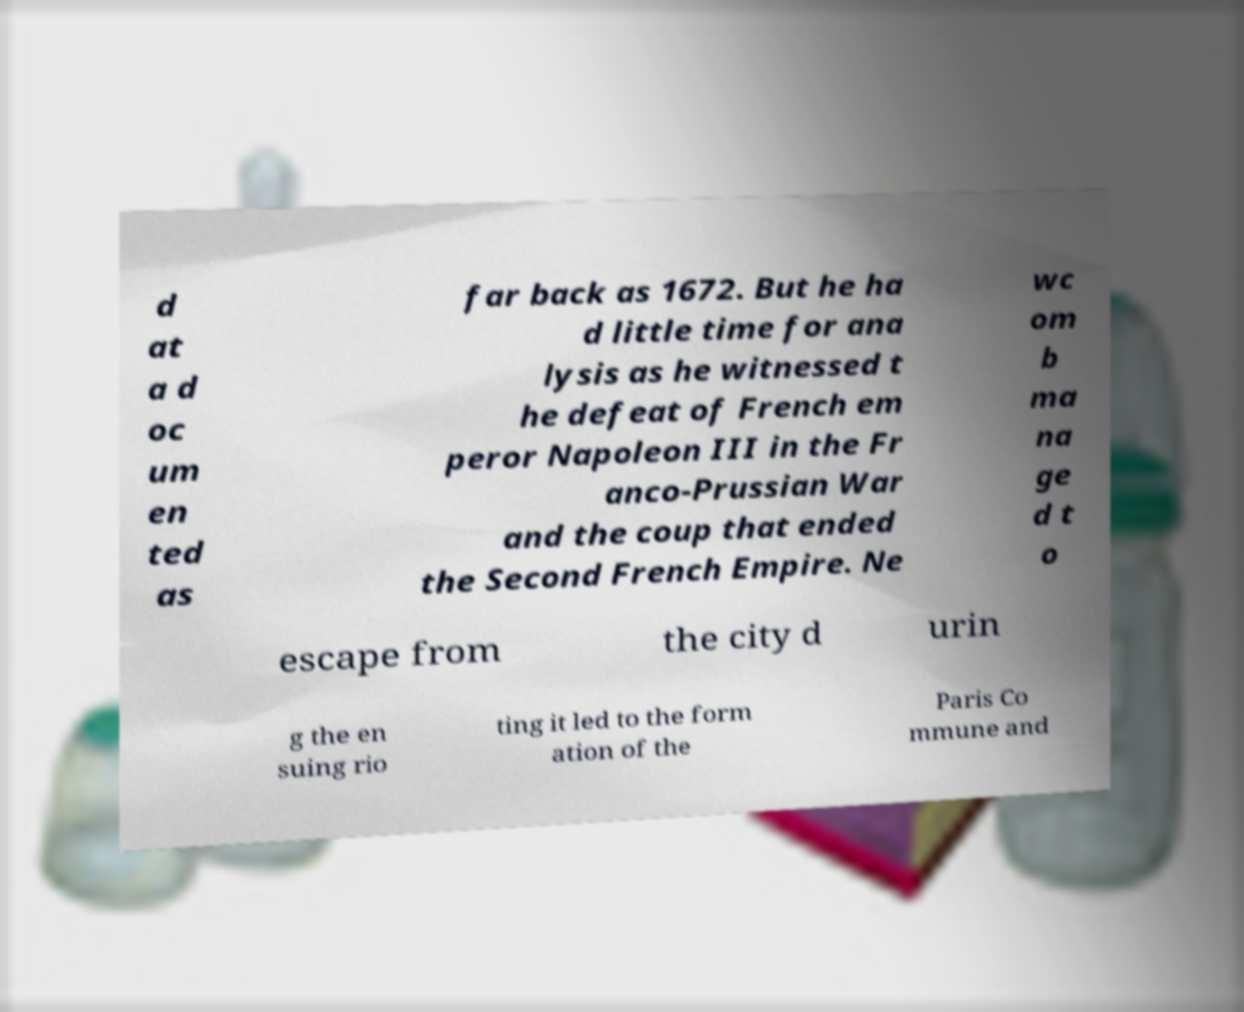Can you read and provide the text displayed in the image?This photo seems to have some interesting text. Can you extract and type it out for me? d at a d oc um en ted as far back as 1672. But he ha d little time for ana lysis as he witnessed t he defeat of French em peror Napoleon III in the Fr anco-Prussian War and the coup that ended the Second French Empire. Ne wc om b ma na ge d t o escape from the city d urin g the en suing rio ting it led to the form ation of the Paris Co mmune and 